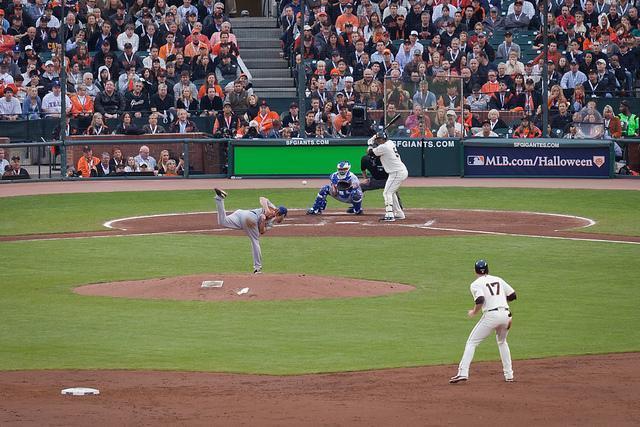How many people are there?
Give a very brief answer. 2. How many giraffes are there?
Give a very brief answer. 0. 